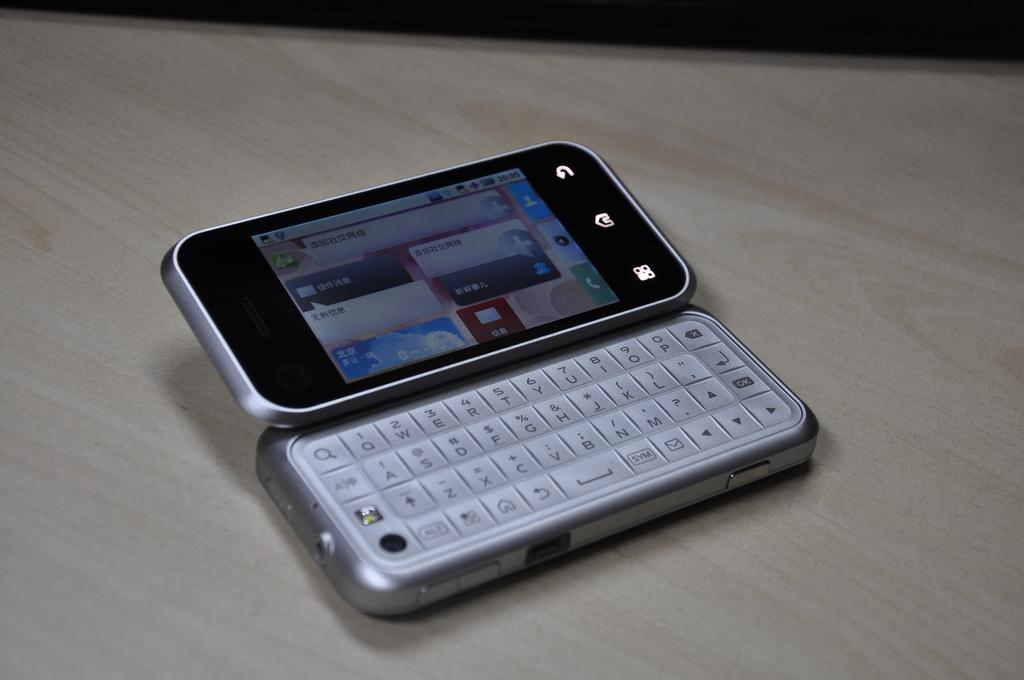<image>
Offer a succinct explanation of the picture presented. A phone with a keyboard open with ASDFG on it. 